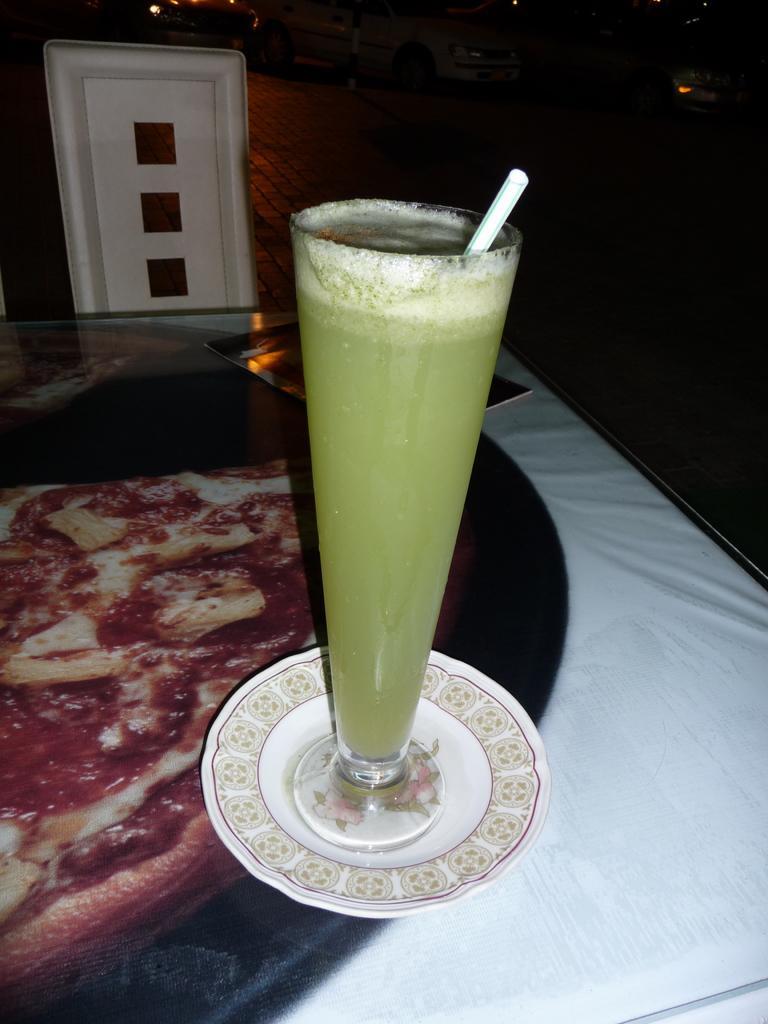Describe this image in one or two sentences. In this picture, we can see the glass with some liquid and straw in it kept on a table and the table is covered with a cloth and we can see some object at the top and the background is dark. 